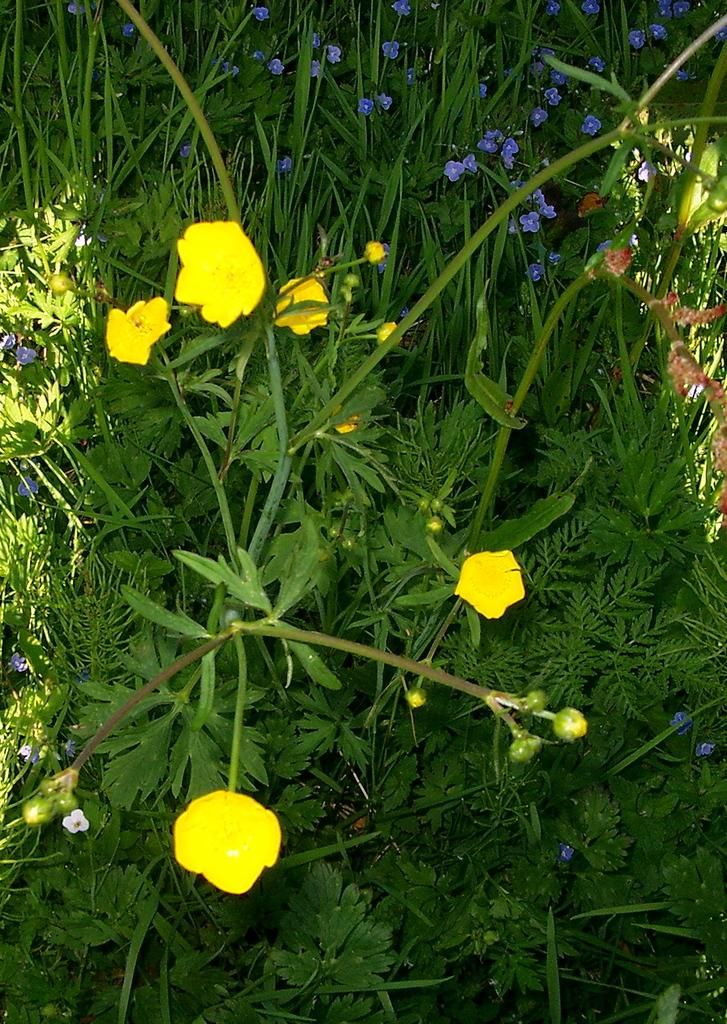What types of plants are visible in the image? There are flowers in the image. What colors are the flowers? The flowers are in yellow and purple colors. What color are the plants that the flowers are on? The plants are in green color. What is the name of the fireman in the image? There is no fireman present in the image; it features flowers and plants. 